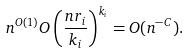Convert formula to latex. <formula><loc_0><loc_0><loc_500><loc_500>n ^ { O ( 1 ) } O \left ( \frac { n r _ { i } } { k _ { i } } \right ) ^ { k _ { i } } = O ( n ^ { - C } ) .</formula> 